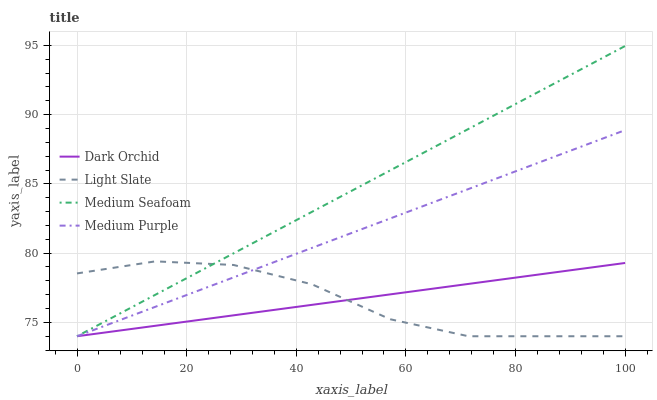Does Light Slate have the minimum area under the curve?
Answer yes or no. Yes. Does Medium Seafoam have the maximum area under the curve?
Answer yes or no. Yes. Does Medium Purple have the minimum area under the curve?
Answer yes or no. No. Does Medium Purple have the maximum area under the curve?
Answer yes or no. No. Is Dark Orchid the smoothest?
Answer yes or no. Yes. Is Light Slate the roughest?
Answer yes or no. Yes. Is Medium Purple the smoothest?
Answer yes or no. No. Is Medium Purple the roughest?
Answer yes or no. No. Does Light Slate have the lowest value?
Answer yes or no. Yes. Does Medium Seafoam have the highest value?
Answer yes or no. Yes. Does Medium Purple have the highest value?
Answer yes or no. No. Does Dark Orchid intersect Medium Purple?
Answer yes or no. Yes. Is Dark Orchid less than Medium Purple?
Answer yes or no. No. Is Dark Orchid greater than Medium Purple?
Answer yes or no. No. 